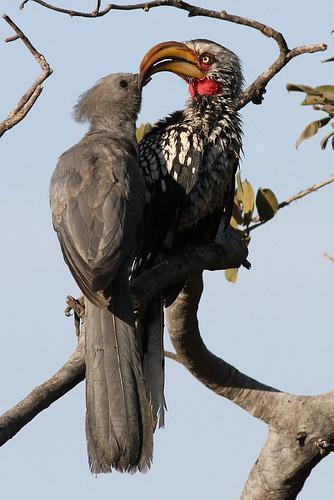How many birds have black and white feathers?
Give a very brief answer. 1. How many beaks?
Give a very brief answer. 2. How many only gray birds?
Give a very brief answer. 1. How many birds?
Give a very brief answer. 2. 